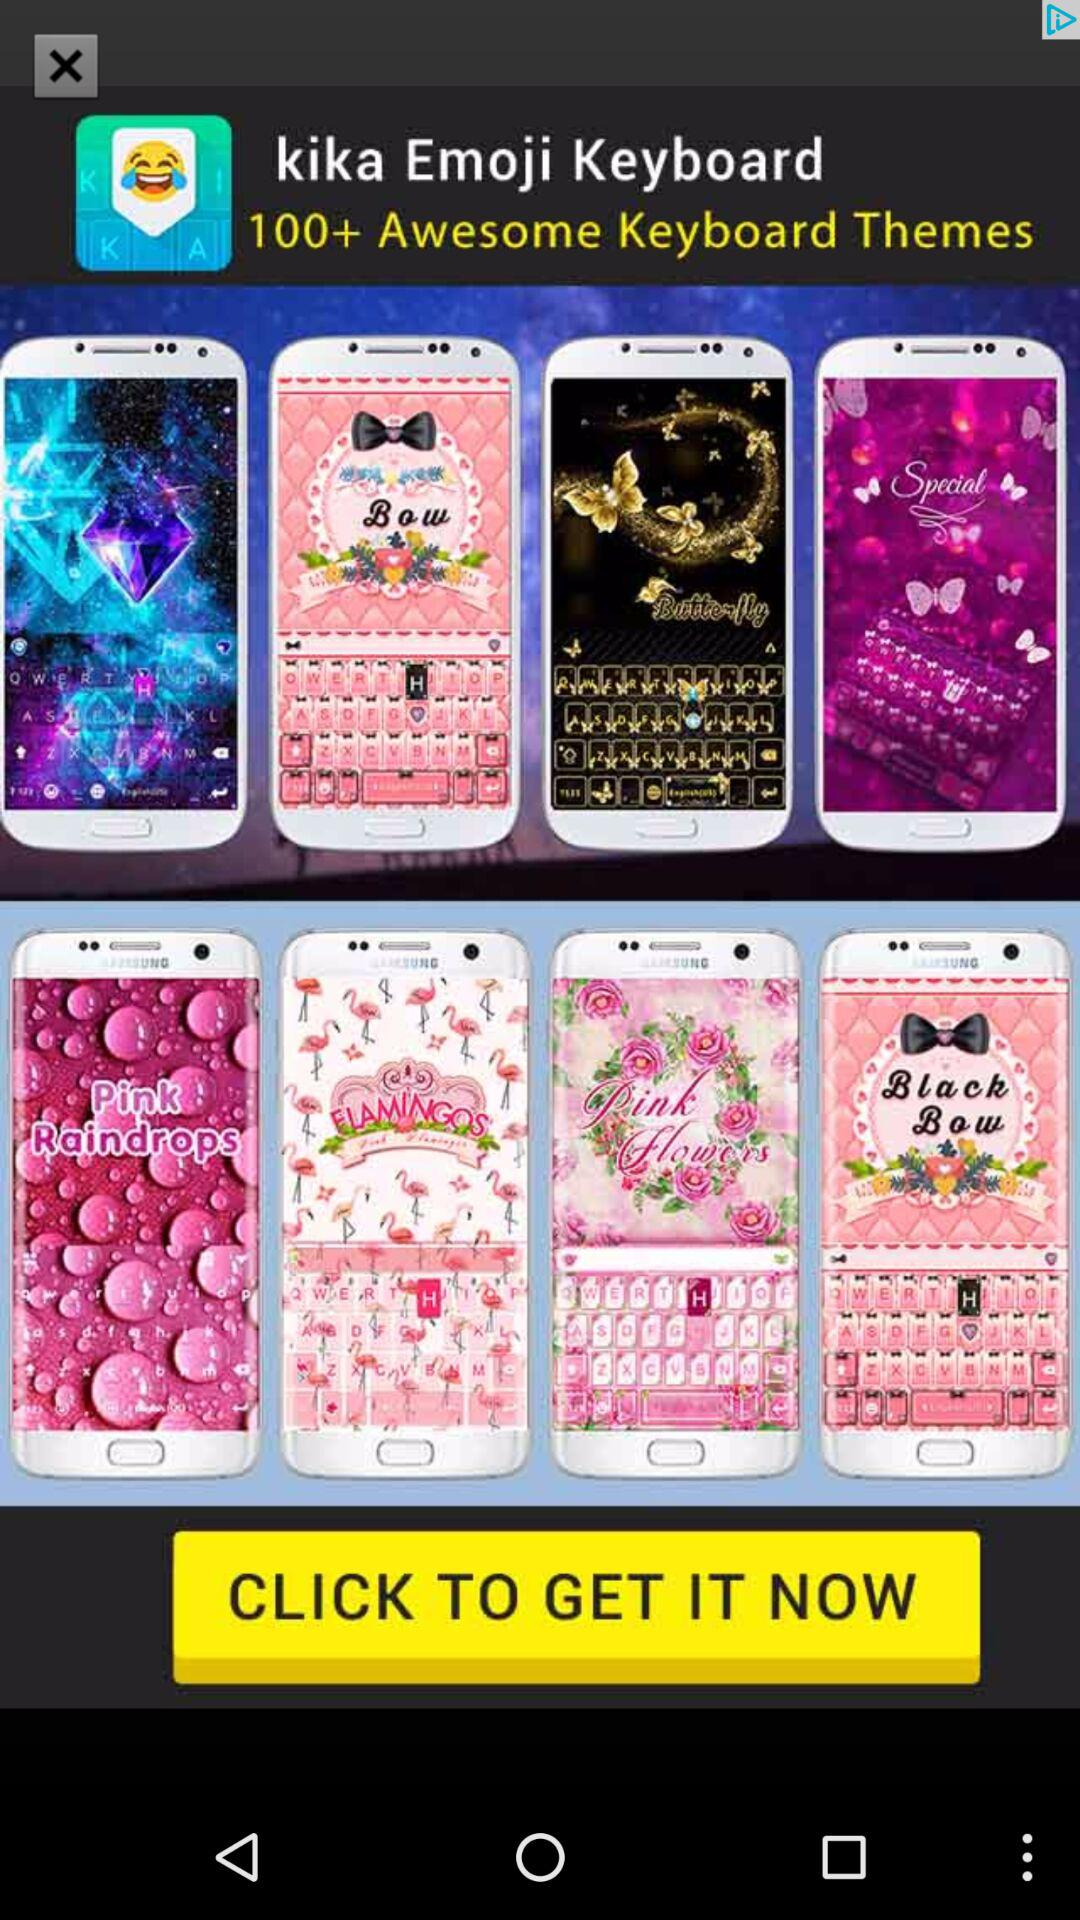How many keyboard themes have a pink theme?
Answer the question using a single word or phrase. 4 